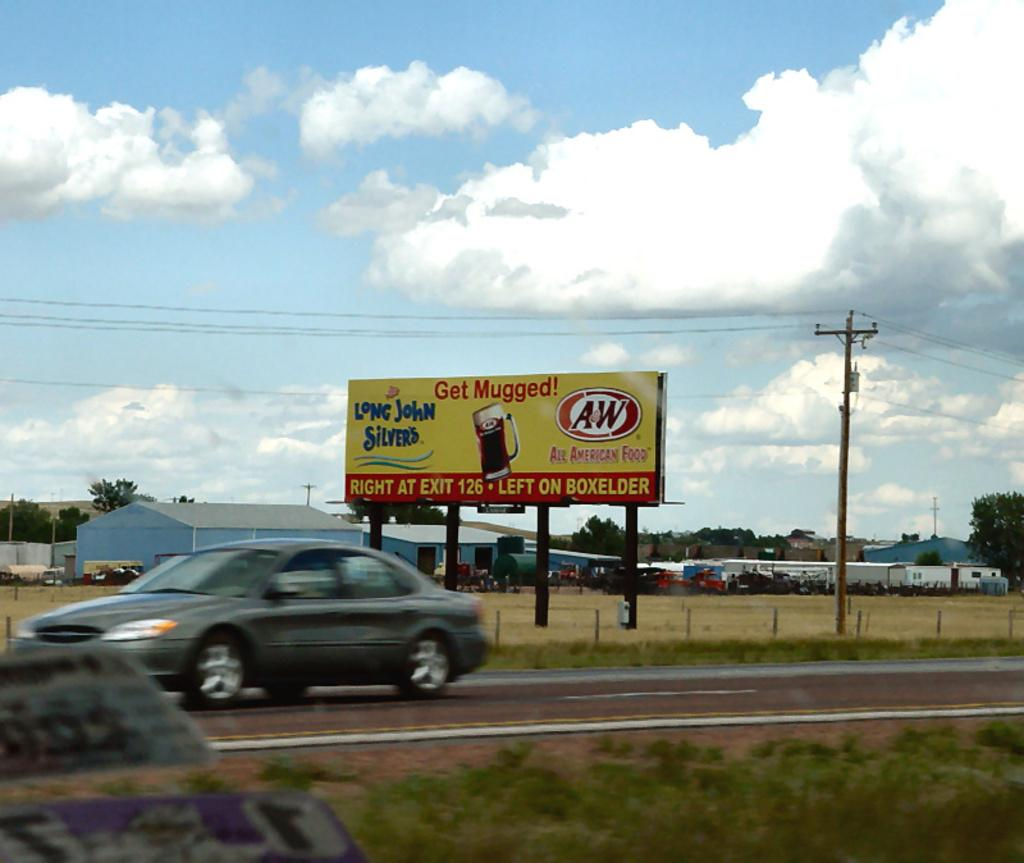<image>
Share a concise interpretation of the image provided. A sign for Long John Silver's is on the side of the road. 